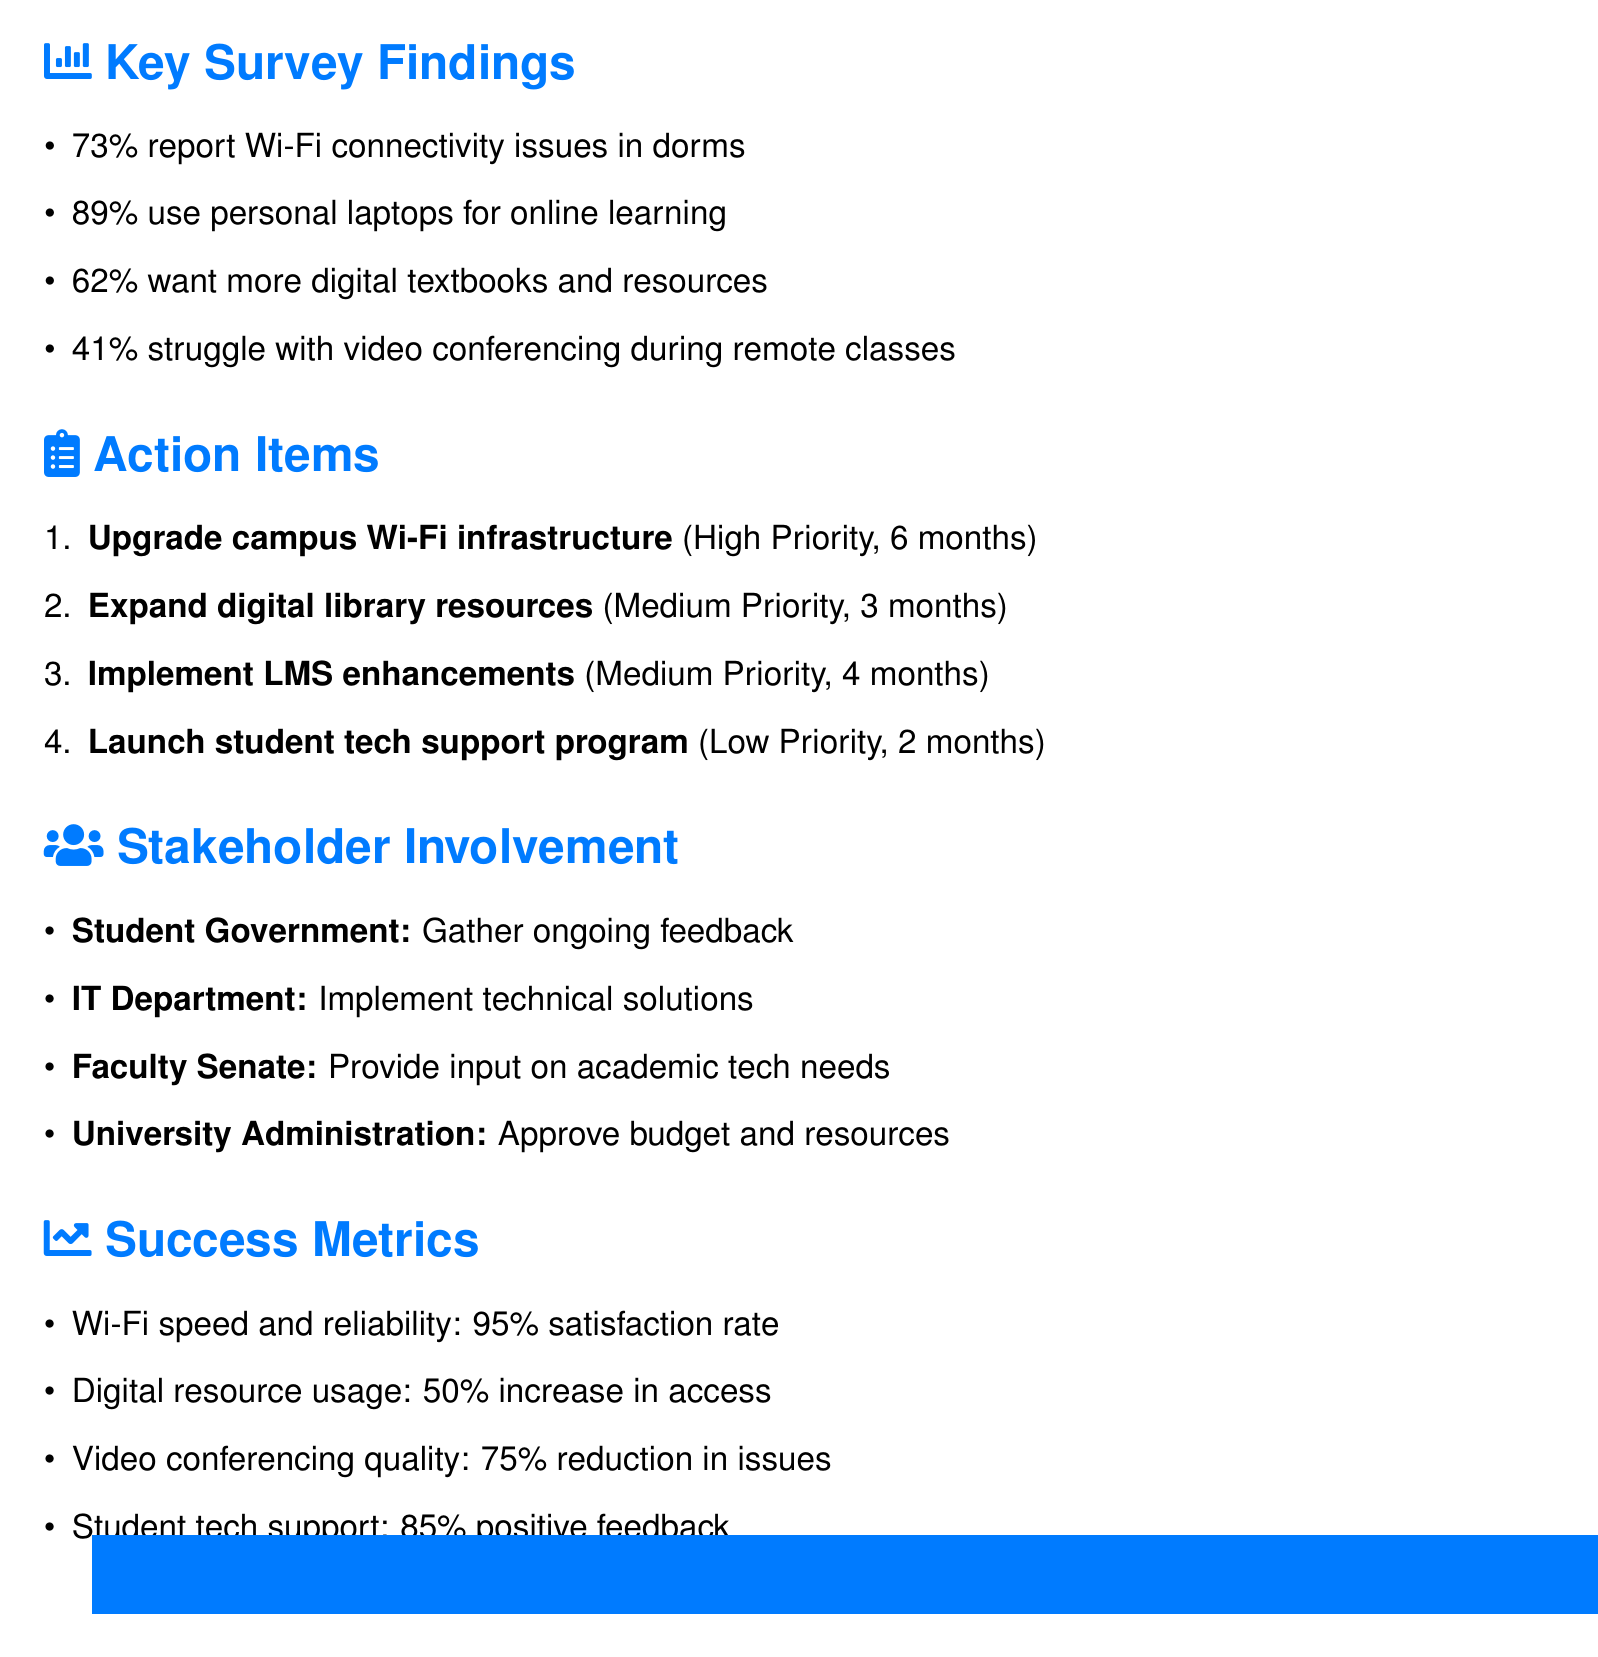What is the total number of respondents? The total number of respondents is stated in the survey results section of the document.
Answer: 1250 What percentage of undergraduates participated in the survey? The undergraduate percentage is provided in the participation section of the survey results.
Answer: 85% What is the priority level for upgrading the campus Wi-Fi infrastructure? The action item for upgrading Wi-Fi infrastructure includes a specified priority level.
Answer: High How long is the timeline for expanding digital library resources? The timeline for each action item is given in the action items section of the document.
Answer: 3 months What percentage of students report Wi-Fi connectivity issues in dorms? This statistic is included in the key findings section of the document.
Answer: 73% What is the target satisfaction rate for Wi-Fi speed and reliability? The success metrics outline the goal for Wi-Fi satisfaction in follow-up surveys.
Answer: 95% What group is responsible for gathering ongoing feedback from students? The role of each stakeholder involved is identified in the stakeholder involvement section of the document.
Answer: Student Government Association What is the planned duration of the implementation phase? The duration of each phase is detailed in the timeline section of the document.
Answer: 6 months How many months is allocated for the student tech support program launch? The time allocated for launching this program is specified in the action items section.
Answer: 2 months 